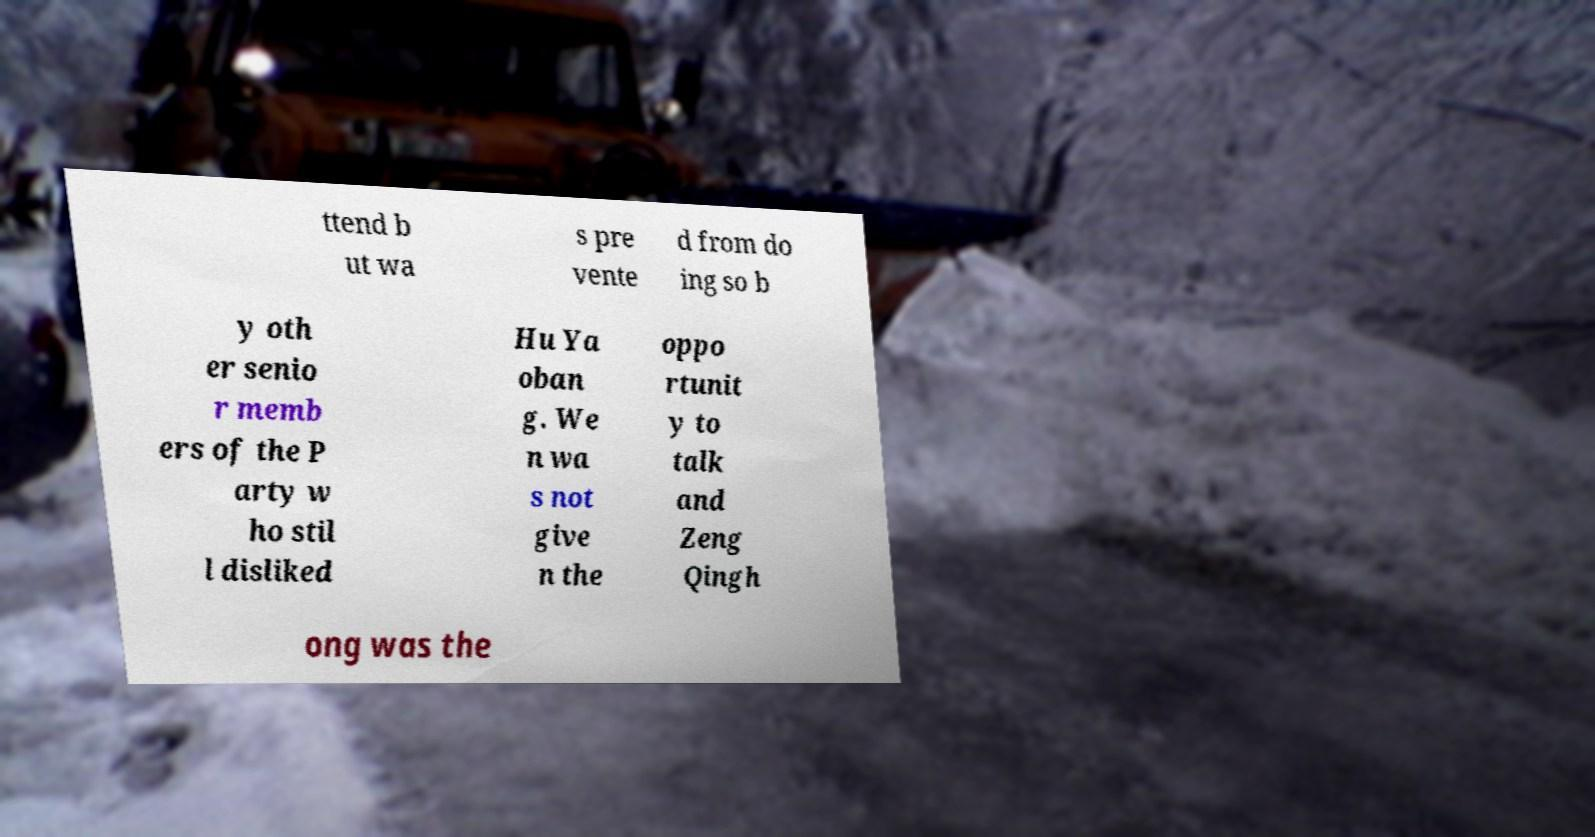Can you accurately transcribe the text from the provided image for me? ttend b ut wa s pre vente d from do ing so b y oth er senio r memb ers of the P arty w ho stil l disliked Hu Ya oban g. We n wa s not give n the oppo rtunit y to talk and Zeng Qingh ong was the 